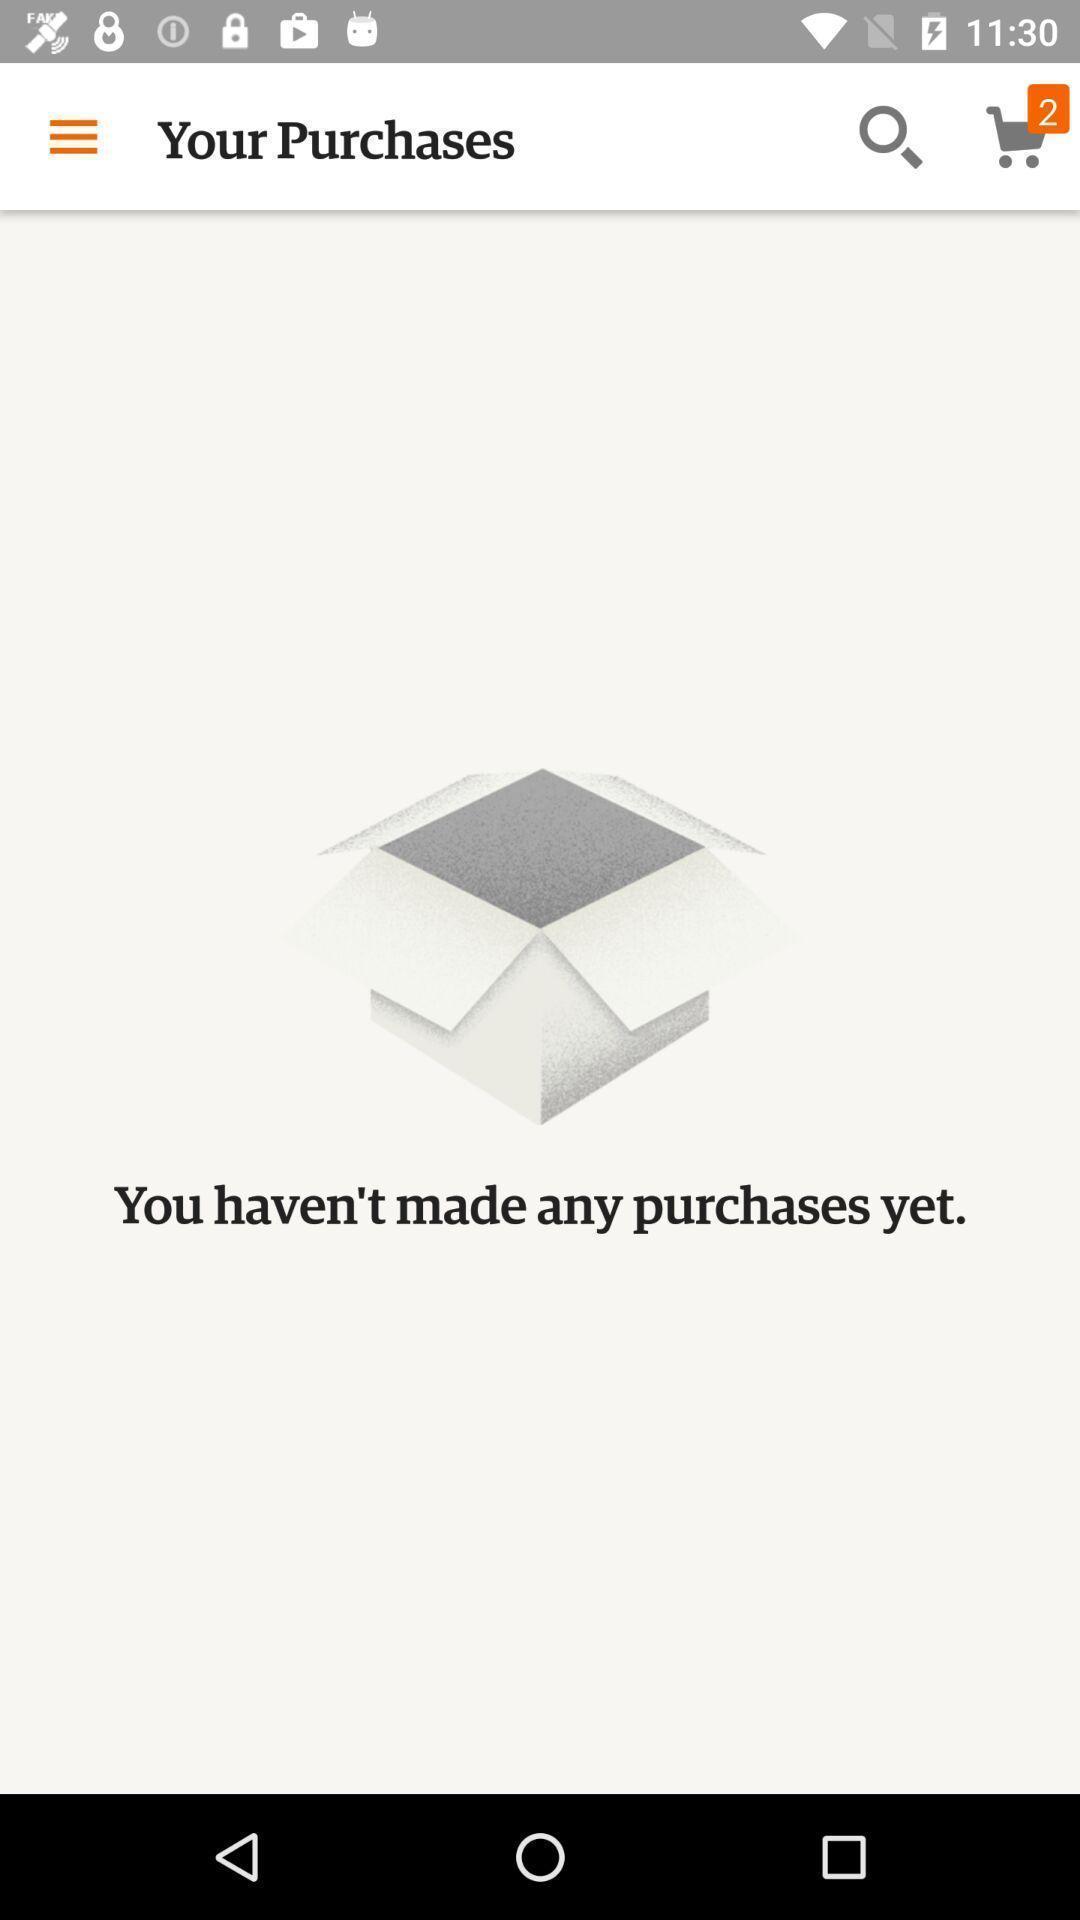Provide a description of this screenshot. Screen displaying purchases page of a shopping app. 